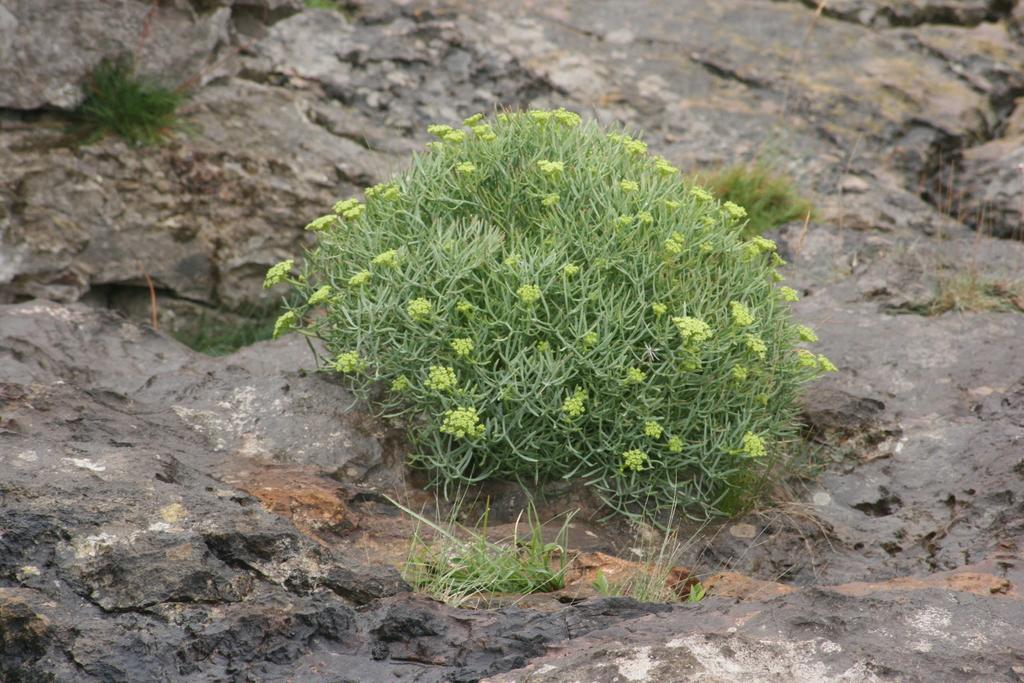What type of living organism can be seen in the image? There is a plant in the image. Where is the plant located? The plant is on a rock surface. What other type of vegetation is present in the image? There is grass in the image. What type of button can be seen on the plant in the image? There is no button present on the plant in the image. 